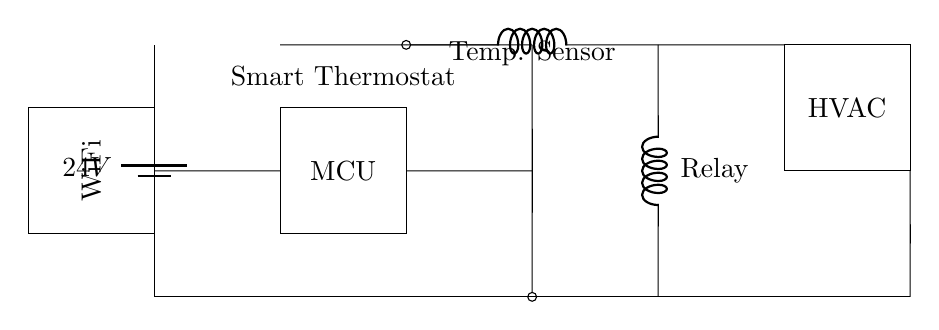What is the main component controlling the circuit? The main component is the microcontroller (MCU), which processes the temperature data and controls the HVAC system accordingly.
Answer: MCU What is the voltage supplied to the circuit? The circuit is powered by a 24V battery, which is indicated by the battery symbol at the top left corner of the diagram.
Answer: 24V How is the temperature measured in this circuit? The temperature is measured using a thermistor, shown as a temperature sensor connected directly to the microcontroller.
Answer: Thermistor What does the relay do in this circuit? The relay acts as a switch that allows the microcontroller to control the HVAC system based on the temperature readings.
Answer: Switch How does the WiFi module interact with the circuit? The WiFi module enables wireless communication, allowing the system to send or receive temperature data remotely.
Answer: Communication What is the function of the HVAC component in the circuit? The HVAC component regulates the temperature in the display areas, activating heating or cooling based on commands from the microcontroller.
Answer: Temperature control What are the ground connections used for in the circuit? Ground connections are used to create a common reference point for the circuit, ensuring that all components operate correctly and safely.
Answer: Common reference 